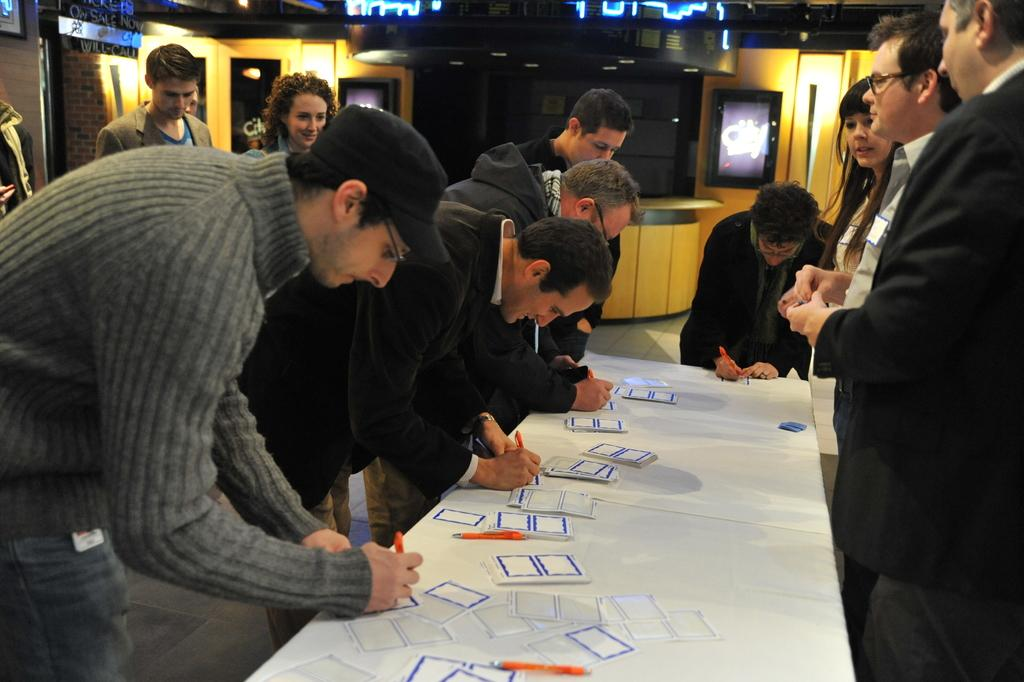What are the people in the image doing around the table? Some of the people are standing around a table, and some of them are writing on labels. Can you describe the gender distribution of the people in the image? There are both men and women present in the image. What sound can be heard coming from the whip in the image? There is no whip present in the image, so it is not possible to determine any associated sounds. 